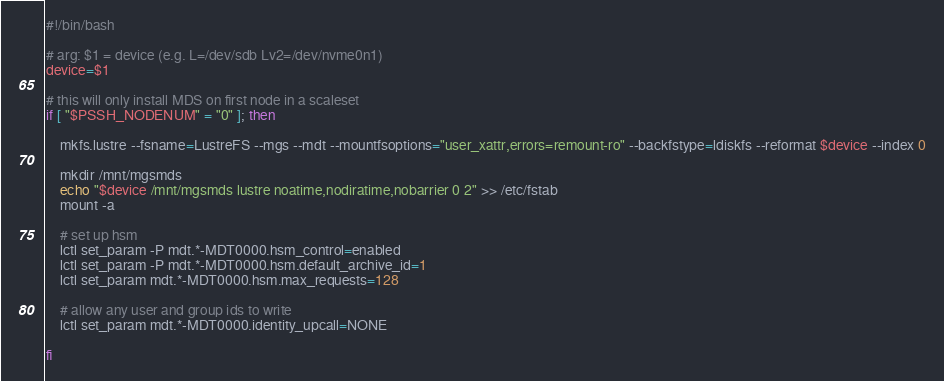<code> <loc_0><loc_0><loc_500><loc_500><_Bash_>#!/bin/bash

# arg: $1 = device (e.g. L=/dev/sdb Lv2=/dev/nvme0n1)
device=$1

# this will only install MDS on first node in a scaleset
if [ "$PSSH_NODENUM" = "0" ]; then

    mkfs.lustre --fsname=LustreFS --mgs --mdt --mountfsoptions="user_xattr,errors=remount-ro" --backfstype=ldiskfs --reformat $device --index 0

    mkdir /mnt/mgsmds
    echo "$device /mnt/mgsmds lustre noatime,nodiratime,nobarrier 0 2" >> /etc/fstab
    mount -a

    # set up hsm
    lctl set_param -P mdt.*-MDT0000.hsm_control=enabled
    lctl set_param -P mdt.*-MDT0000.hsm.default_archive_id=1
    lctl set_param mdt.*-MDT0000.hsm.max_requests=128

    # allow any user and group ids to write
    lctl set_param mdt.*-MDT0000.identity_upcall=NONE

fi</code> 